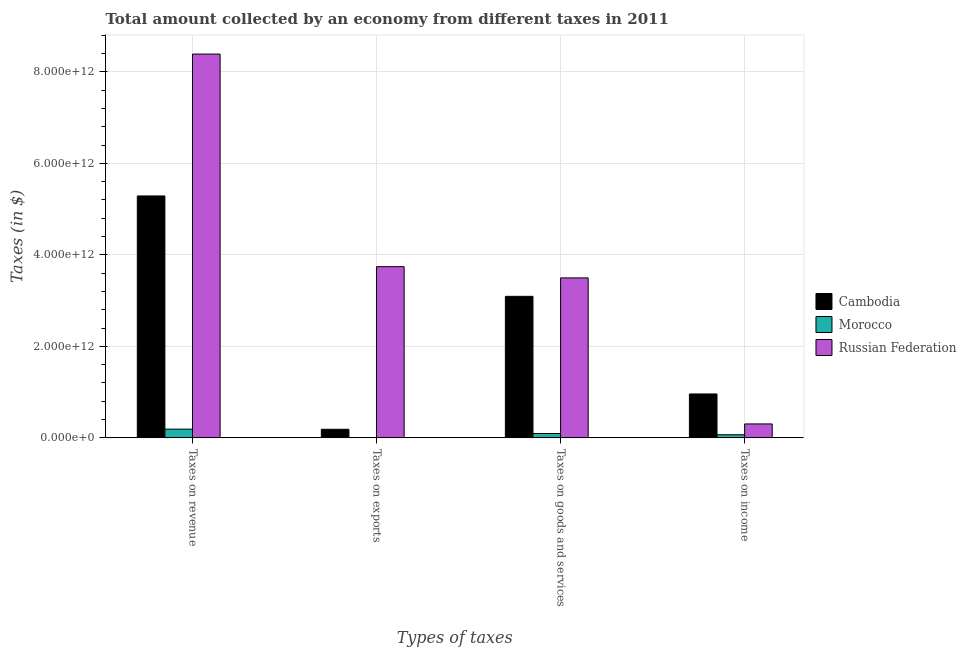Are the number of bars on each tick of the X-axis equal?
Make the answer very short. Yes. How many bars are there on the 1st tick from the left?
Provide a short and direct response. 3. How many bars are there on the 1st tick from the right?
Offer a terse response. 3. What is the label of the 1st group of bars from the left?
Provide a short and direct response. Taxes on revenue. What is the amount collected as tax on revenue in Russian Federation?
Provide a succinct answer. 8.39e+12. Across all countries, what is the maximum amount collected as tax on revenue?
Make the answer very short. 8.39e+12. Across all countries, what is the minimum amount collected as tax on exports?
Ensure brevity in your answer.  3.00e+09. In which country was the amount collected as tax on income maximum?
Your answer should be very brief. Cambodia. In which country was the amount collected as tax on goods minimum?
Keep it short and to the point. Morocco. What is the total amount collected as tax on exports in the graph?
Provide a short and direct response. 3.93e+12. What is the difference between the amount collected as tax on exports in Morocco and that in Cambodia?
Your answer should be compact. -1.85e+11. What is the difference between the amount collected as tax on goods in Russian Federation and the amount collected as tax on exports in Morocco?
Provide a short and direct response. 3.49e+12. What is the average amount collected as tax on goods per country?
Your response must be concise. 2.23e+12. What is the difference between the amount collected as tax on exports and amount collected as tax on income in Russian Federation?
Make the answer very short. 3.44e+12. What is the ratio of the amount collected as tax on income in Russian Federation to that in Cambodia?
Your answer should be very brief. 0.32. Is the amount collected as tax on exports in Cambodia less than that in Russian Federation?
Offer a very short reply. Yes. What is the difference between the highest and the second highest amount collected as tax on revenue?
Provide a succinct answer. 3.10e+12. What is the difference between the highest and the lowest amount collected as tax on goods?
Provide a short and direct response. 3.40e+12. What does the 2nd bar from the left in Taxes on goods and services represents?
Your answer should be very brief. Morocco. What does the 3rd bar from the right in Taxes on goods and services represents?
Offer a very short reply. Cambodia. Is it the case that in every country, the sum of the amount collected as tax on revenue and amount collected as tax on exports is greater than the amount collected as tax on goods?
Provide a short and direct response. Yes. How many countries are there in the graph?
Provide a short and direct response. 3. What is the difference between two consecutive major ticks on the Y-axis?
Your answer should be very brief. 2.00e+12. Are the values on the major ticks of Y-axis written in scientific E-notation?
Offer a very short reply. Yes. Does the graph contain grids?
Keep it short and to the point. Yes. What is the title of the graph?
Make the answer very short. Total amount collected by an economy from different taxes in 2011. Does "Bermuda" appear as one of the legend labels in the graph?
Ensure brevity in your answer.  No. What is the label or title of the X-axis?
Offer a very short reply. Types of taxes. What is the label or title of the Y-axis?
Your answer should be compact. Taxes (in $). What is the Taxes (in $) in Cambodia in Taxes on revenue?
Provide a short and direct response. 5.29e+12. What is the Taxes (in $) in Morocco in Taxes on revenue?
Make the answer very short. 1.91e+11. What is the Taxes (in $) in Russian Federation in Taxes on revenue?
Keep it short and to the point. 8.39e+12. What is the Taxes (in $) in Cambodia in Taxes on exports?
Keep it short and to the point. 1.88e+11. What is the Taxes (in $) of Morocco in Taxes on exports?
Provide a short and direct response. 3.00e+09. What is the Taxes (in $) of Russian Federation in Taxes on exports?
Provide a succinct answer. 3.74e+12. What is the Taxes (in $) in Cambodia in Taxes on goods and services?
Ensure brevity in your answer.  3.09e+12. What is the Taxes (in $) of Morocco in Taxes on goods and services?
Keep it short and to the point. 9.52e+1. What is the Taxes (in $) in Russian Federation in Taxes on goods and services?
Provide a short and direct response. 3.50e+12. What is the Taxes (in $) in Cambodia in Taxes on income?
Offer a very short reply. 9.60e+11. What is the Taxes (in $) in Morocco in Taxes on income?
Your answer should be very brief. 6.85e+1. What is the Taxes (in $) in Russian Federation in Taxes on income?
Your response must be concise. 3.05e+11. Across all Types of taxes, what is the maximum Taxes (in $) in Cambodia?
Provide a succinct answer. 5.29e+12. Across all Types of taxes, what is the maximum Taxes (in $) in Morocco?
Keep it short and to the point. 1.91e+11. Across all Types of taxes, what is the maximum Taxes (in $) in Russian Federation?
Keep it short and to the point. 8.39e+12. Across all Types of taxes, what is the minimum Taxes (in $) of Cambodia?
Your response must be concise. 1.88e+11. Across all Types of taxes, what is the minimum Taxes (in $) of Morocco?
Offer a terse response. 3.00e+09. Across all Types of taxes, what is the minimum Taxes (in $) in Russian Federation?
Your answer should be very brief. 3.05e+11. What is the total Taxes (in $) of Cambodia in the graph?
Ensure brevity in your answer.  9.53e+12. What is the total Taxes (in $) in Morocco in the graph?
Provide a succinct answer. 3.58e+11. What is the total Taxes (in $) of Russian Federation in the graph?
Make the answer very short. 1.59e+13. What is the difference between the Taxes (in $) in Cambodia in Taxes on revenue and that in Taxes on exports?
Provide a short and direct response. 5.10e+12. What is the difference between the Taxes (in $) in Morocco in Taxes on revenue and that in Taxes on exports?
Offer a very short reply. 1.88e+11. What is the difference between the Taxes (in $) in Russian Federation in Taxes on revenue and that in Taxes on exports?
Offer a terse response. 4.65e+12. What is the difference between the Taxes (in $) in Cambodia in Taxes on revenue and that in Taxes on goods and services?
Offer a very short reply. 2.19e+12. What is the difference between the Taxes (in $) in Morocco in Taxes on revenue and that in Taxes on goods and services?
Ensure brevity in your answer.  9.58e+1. What is the difference between the Taxes (in $) in Russian Federation in Taxes on revenue and that in Taxes on goods and services?
Your answer should be compact. 4.89e+12. What is the difference between the Taxes (in $) of Cambodia in Taxes on revenue and that in Taxes on income?
Your answer should be very brief. 4.33e+12. What is the difference between the Taxes (in $) of Morocco in Taxes on revenue and that in Taxes on income?
Give a very brief answer. 1.23e+11. What is the difference between the Taxes (in $) in Russian Federation in Taxes on revenue and that in Taxes on income?
Give a very brief answer. 8.08e+12. What is the difference between the Taxes (in $) of Cambodia in Taxes on exports and that in Taxes on goods and services?
Offer a very short reply. -2.91e+12. What is the difference between the Taxes (in $) of Morocco in Taxes on exports and that in Taxes on goods and services?
Make the answer very short. -9.22e+1. What is the difference between the Taxes (in $) of Russian Federation in Taxes on exports and that in Taxes on goods and services?
Offer a terse response. 2.46e+11. What is the difference between the Taxes (in $) of Cambodia in Taxes on exports and that in Taxes on income?
Provide a short and direct response. -7.72e+11. What is the difference between the Taxes (in $) of Morocco in Taxes on exports and that in Taxes on income?
Ensure brevity in your answer.  -6.55e+1. What is the difference between the Taxes (in $) of Russian Federation in Taxes on exports and that in Taxes on income?
Offer a terse response. 3.44e+12. What is the difference between the Taxes (in $) of Cambodia in Taxes on goods and services and that in Taxes on income?
Provide a short and direct response. 2.13e+12. What is the difference between the Taxes (in $) of Morocco in Taxes on goods and services and that in Taxes on income?
Your answer should be very brief. 2.68e+1. What is the difference between the Taxes (in $) in Russian Federation in Taxes on goods and services and that in Taxes on income?
Your answer should be very brief. 3.19e+12. What is the difference between the Taxes (in $) in Cambodia in Taxes on revenue and the Taxes (in $) in Morocco in Taxes on exports?
Provide a succinct answer. 5.28e+12. What is the difference between the Taxes (in $) of Cambodia in Taxes on revenue and the Taxes (in $) of Russian Federation in Taxes on exports?
Your response must be concise. 1.55e+12. What is the difference between the Taxes (in $) in Morocco in Taxes on revenue and the Taxes (in $) in Russian Federation in Taxes on exports?
Your answer should be compact. -3.55e+12. What is the difference between the Taxes (in $) of Cambodia in Taxes on revenue and the Taxes (in $) of Morocco in Taxes on goods and services?
Give a very brief answer. 5.19e+12. What is the difference between the Taxes (in $) in Cambodia in Taxes on revenue and the Taxes (in $) in Russian Federation in Taxes on goods and services?
Provide a short and direct response. 1.79e+12. What is the difference between the Taxes (in $) in Morocco in Taxes on revenue and the Taxes (in $) in Russian Federation in Taxes on goods and services?
Offer a terse response. -3.31e+12. What is the difference between the Taxes (in $) of Cambodia in Taxes on revenue and the Taxes (in $) of Morocco in Taxes on income?
Your response must be concise. 5.22e+12. What is the difference between the Taxes (in $) of Cambodia in Taxes on revenue and the Taxes (in $) of Russian Federation in Taxes on income?
Give a very brief answer. 4.98e+12. What is the difference between the Taxes (in $) in Morocco in Taxes on revenue and the Taxes (in $) in Russian Federation in Taxes on income?
Provide a short and direct response. -1.14e+11. What is the difference between the Taxes (in $) of Cambodia in Taxes on exports and the Taxes (in $) of Morocco in Taxes on goods and services?
Make the answer very short. 9.28e+1. What is the difference between the Taxes (in $) of Cambodia in Taxes on exports and the Taxes (in $) of Russian Federation in Taxes on goods and services?
Provide a succinct answer. -3.31e+12. What is the difference between the Taxes (in $) of Morocco in Taxes on exports and the Taxes (in $) of Russian Federation in Taxes on goods and services?
Offer a terse response. -3.49e+12. What is the difference between the Taxes (in $) of Cambodia in Taxes on exports and the Taxes (in $) of Morocco in Taxes on income?
Provide a short and direct response. 1.20e+11. What is the difference between the Taxes (in $) in Cambodia in Taxes on exports and the Taxes (in $) in Russian Federation in Taxes on income?
Offer a very short reply. -1.17e+11. What is the difference between the Taxes (in $) of Morocco in Taxes on exports and the Taxes (in $) of Russian Federation in Taxes on income?
Ensure brevity in your answer.  -3.02e+11. What is the difference between the Taxes (in $) of Cambodia in Taxes on goods and services and the Taxes (in $) of Morocco in Taxes on income?
Your response must be concise. 3.02e+12. What is the difference between the Taxes (in $) in Cambodia in Taxes on goods and services and the Taxes (in $) in Russian Federation in Taxes on income?
Keep it short and to the point. 2.79e+12. What is the difference between the Taxes (in $) of Morocco in Taxes on goods and services and the Taxes (in $) of Russian Federation in Taxes on income?
Your answer should be compact. -2.09e+11. What is the average Taxes (in $) in Cambodia per Types of taxes?
Ensure brevity in your answer.  2.38e+12. What is the average Taxes (in $) of Morocco per Types of taxes?
Make the answer very short. 8.94e+1. What is the average Taxes (in $) of Russian Federation per Types of taxes?
Give a very brief answer. 3.98e+12. What is the difference between the Taxes (in $) in Cambodia and Taxes (in $) in Morocco in Taxes on revenue?
Make the answer very short. 5.10e+12. What is the difference between the Taxes (in $) of Cambodia and Taxes (in $) of Russian Federation in Taxes on revenue?
Provide a succinct answer. -3.10e+12. What is the difference between the Taxes (in $) of Morocco and Taxes (in $) of Russian Federation in Taxes on revenue?
Ensure brevity in your answer.  -8.20e+12. What is the difference between the Taxes (in $) in Cambodia and Taxes (in $) in Morocco in Taxes on exports?
Offer a terse response. 1.85e+11. What is the difference between the Taxes (in $) in Cambodia and Taxes (in $) in Russian Federation in Taxes on exports?
Provide a succinct answer. -3.55e+12. What is the difference between the Taxes (in $) of Morocco and Taxes (in $) of Russian Federation in Taxes on exports?
Offer a terse response. -3.74e+12. What is the difference between the Taxes (in $) in Cambodia and Taxes (in $) in Morocco in Taxes on goods and services?
Your response must be concise. 3.00e+12. What is the difference between the Taxes (in $) in Cambodia and Taxes (in $) in Russian Federation in Taxes on goods and services?
Offer a very short reply. -4.03e+11. What is the difference between the Taxes (in $) in Morocco and Taxes (in $) in Russian Federation in Taxes on goods and services?
Your answer should be compact. -3.40e+12. What is the difference between the Taxes (in $) of Cambodia and Taxes (in $) of Morocco in Taxes on income?
Ensure brevity in your answer.  8.91e+11. What is the difference between the Taxes (in $) in Cambodia and Taxes (in $) in Russian Federation in Taxes on income?
Your answer should be compact. 6.55e+11. What is the difference between the Taxes (in $) in Morocco and Taxes (in $) in Russian Federation in Taxes on income?
Your response must be concise. -2.36e+11. What is the ratio of the Taxes (in $) of Cambodia in Taxes on revenue to that in Taxes on exports?
Offer a very short reply. 28.12. What is the ratio of the Taxes (in $) of Morocco in Taxes on revenue to that in Taxes on exports?
Offer a terse response. 63.68. What is the ratio of the Taxes (in $) in Russian Federation in Taxes on revenue to that in Taxes on exports?
Provide a short and direct response. 2.24. What is the ratio of the Taxes (in $) in Cambodia in Taxes on revenue to that in Taxes on goods and services?
Ensure brevity in your answer.  1.71. What is the ratio of the Taxes (in $) of Morocco in Taxes on revenue to that in Taxes on goods and services?
Give a very brief answer. 2.01. What is the ratio of the Taxes (in $) of Russian Federation in Taxes on revenue to that in Taxes on goods and services?
Offer a very short reply. 2.4. What is the ratio of the Taxes (in $) of Cambodia in Taxes on revenue to that in Taxes on income?
Ensure brevity in your answer.  5.51. What is the ratio of the Taxes (in $) in Morocco in Taxes on revenue to that in Taxes on income?
Make the answer very short. 2.79. What is the ratio of the Taxes (in $) in Russian Federation in Taxes on revenue to that in Taxes on income?
Provide a succinct answer. 27.54. What is the ratio of the Taxes (in $) of Cambodia in Taxes on exports to that in Taxes on goods and services?
Offer a very short reply. 0.06. What is the ratio of the Taxes (in $) of Morocco in Taxes on exports to that in Taxes on goods and services?
Keep it short and to the point. 0.03. What is the ratio of the Taxes (in $) of Russian Federation in Taxes on exports to that in Taxes on goods and services?
Give a very brief answer. 1.07. What is the ratio of the Taxes (in $) of Cambodia in Taxes on exports to that in Taxes on income?
Offer a very short reply. 0.2. What is the ratio of the Taxes (in $) in Morocco in Taxes on exports to that in Taxes on income?
Offer a very short reply. 0.04. What is the ratio of the Taxes (in $) of Russian Federation in Taxes on exports to that in Taxes on income?
Your answer should be compact. 12.28. What is the ratio of the Taxes (in $) of Cambodia in Taxes on goods and services to that in Taxes on income?
Keep it short and to the point. 3.22. What is the ratio of the Taxes (in $) in Morocco in Taxes on goods and services to that in Taxes on income?
Make the answer very short. 1.39. What is the ratio of the Taxes (in $) in Russian Federation in Taxes on goods and services to that in Taxes on income?
Ensure brevity in your answer.  11.48. What is the difference between the highest and the second highest Taxes (in $) in Cambodia?
Give a very brief answer. 2.19e+12. What is the difference between the highest and the second highest Taxes (in $) in Morocco?
Your response must be concise. 9.58e+1. What is the difference between the highest and the second highest Taxes (in $) of Russian Federation?
Ensure brevity in your answer.  4.65e+12. What is the difference between the highest and the lowest Taxes (in $) in Cambodia?
Give a very brief answer. 5.10e+12. What is the difference between the highest and the lowest Taxes (in $) of Morocco?
Ensure brevity in your answer.  1.88e+11. What is the difference between the highest and the lowest Taxes (in $) in Russian Federation?
Your answer should be very brief. 8.08e+12. 